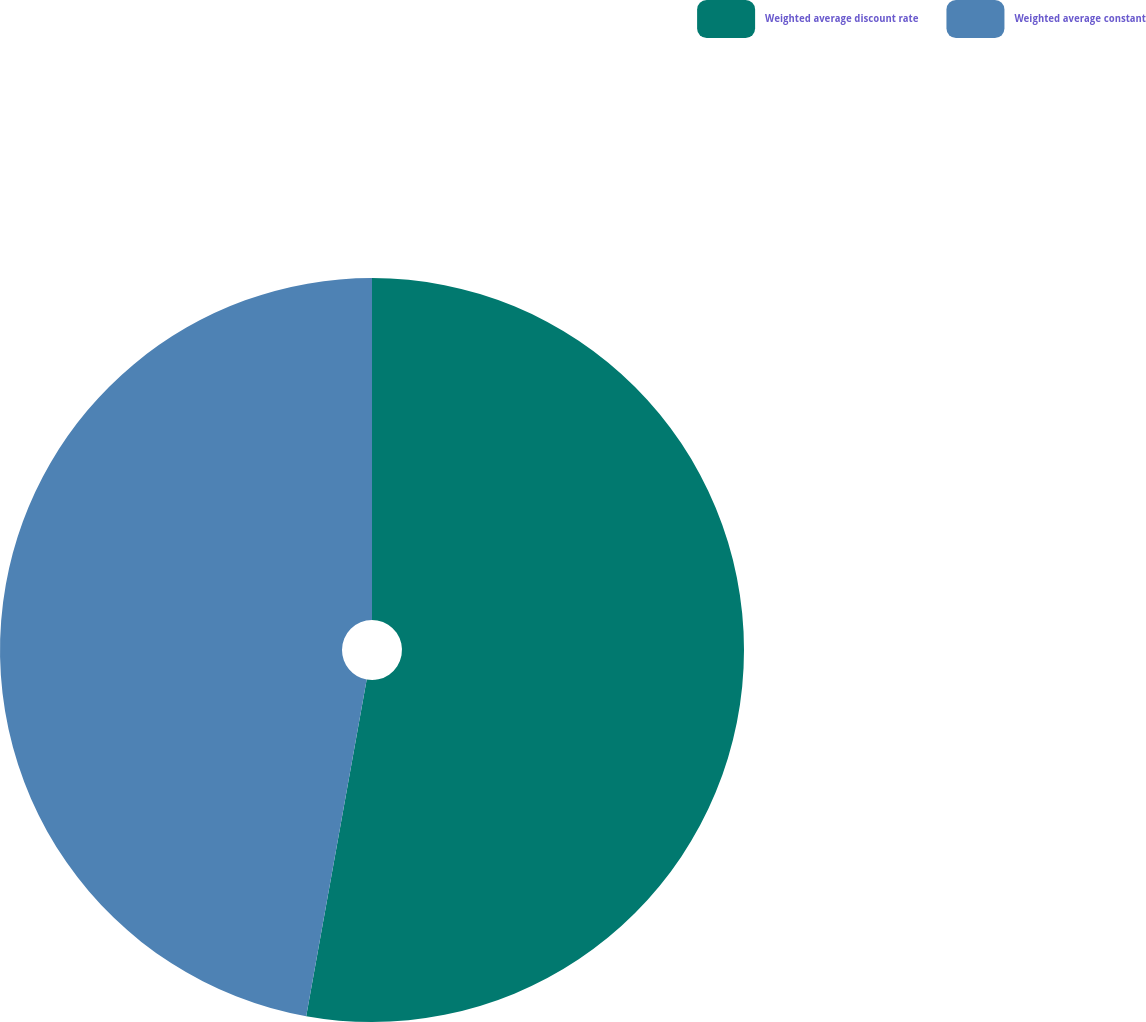Convert chart to OTSL. <chart><loc_0><loc_0><loc_500><loc_500><pie_chart><fcel>Weighted average discount rate<fcel>Weighted average constant<nl><fcel>52.83%<fcel>47.17%<nl></chart> 